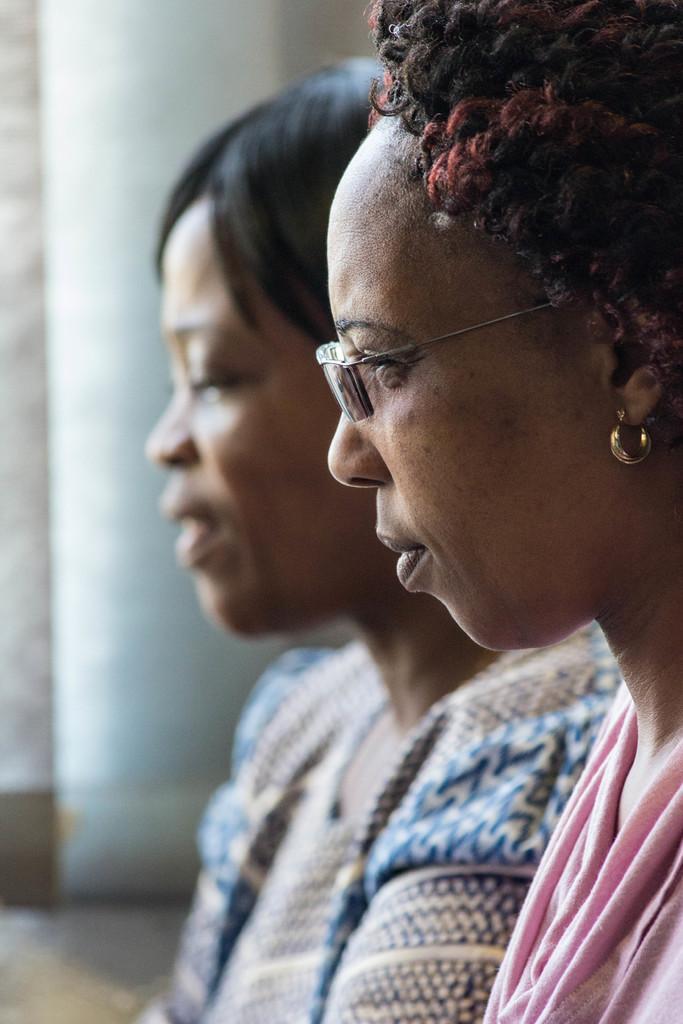Could you give a brief overview of what you see in this image? There are two women and this woman wore spectacle. In the background it is blur. 